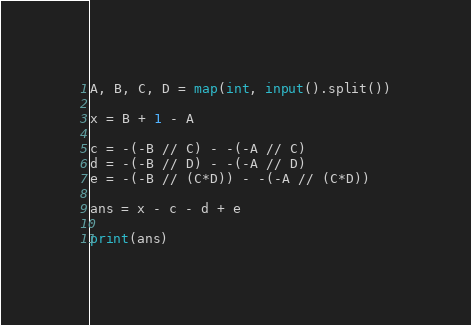<code> <loc_0><loc_0><loc_500><loc_500><_Python_>A, B, C, D = map(int, input().split())

x = B + 1 - A

c = -(-B // C) - -(-A // C)
d = -(-B // D) - -(-A // D)
e = -(-B // (C*D)) - -(-A // (C*D))

ans = x - c - d + e

print(ans)
</code> 